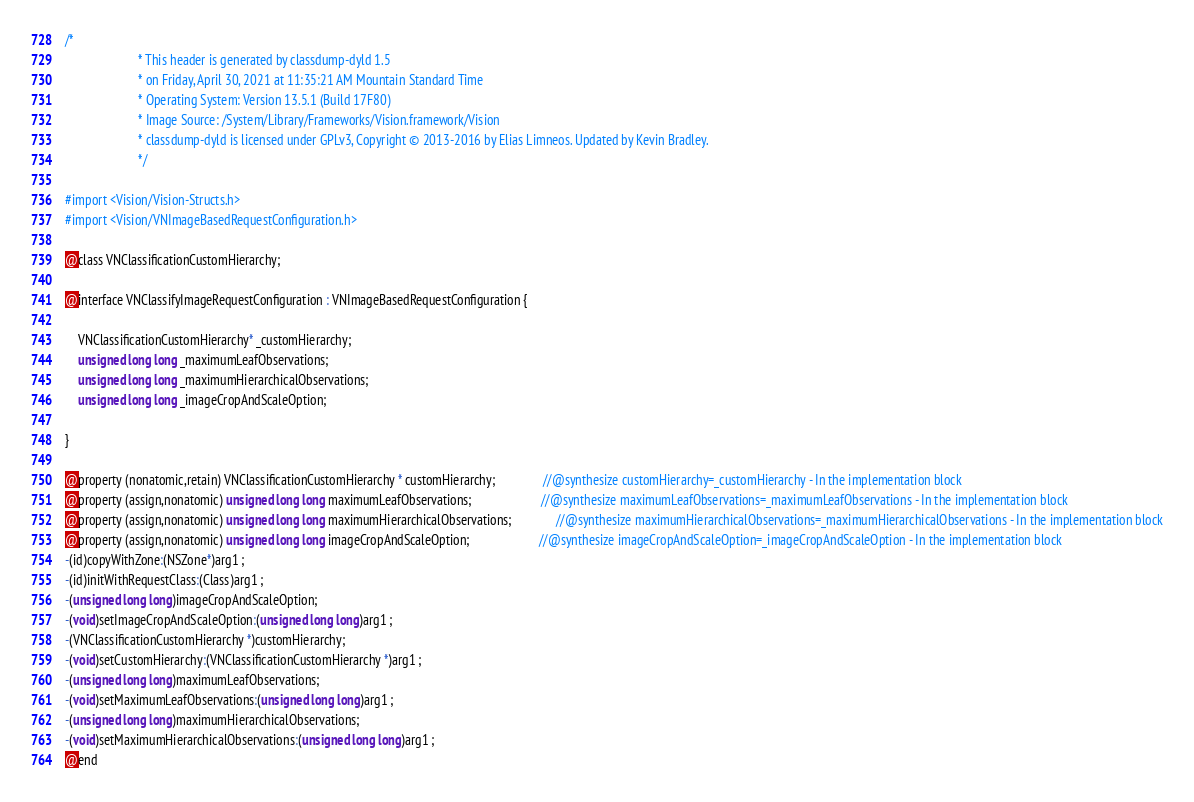<code> <loc_0><loc_0><loc_500><loc_500><_C_>/*
                       * This header is generated by classdump-dyld 1.5
                       * on Friday, April 30, 2021 at 11:35:21 AM Mountain Standard Time
                       * Operating System: Version 13.5.1 (Build 17F80)
                       * Image Source: /System/Library/Frameworks/Vision.framework/Vision
                       * classdump-dyld is licensed under GPLv3, Copyright © 2013-2016 by Elias Limneos. Updated by Kevin Bradley.
                       */

#import <Vision/Vision-Structs.h>
#import <Vision/VNImageBasedRequestConfiguration.h>

@class VNClassificationCustomHierarchy;

@interface VNClassifyImageRequestConfiguration : VNImageBasedRequestConfiguration {

	VNClassificationCustomHierarchy* _customHierarchy;
	unsigned long long _maximumLeafObservations;
	unsigned long long _maximumHierarchicalObservations;
	unsigned long long _imageCropAndScaleOption;

}

@property (nonatomic,retain) VNClassificationCustomHierarchy * customHierarchy;               //@synthesize customHierarchy=_customHierarchy - In the implementation block
@property (assign,nonatomic) unsigned long long maximumLeafObservations;                      //@synthesize maximumLeafObservations=_maximumLeafObservations - In the implementation block
@property (assign,nonatomic) unsigned long long maximumHierarchicalObservations;              //@synthesize maximumHierarchicalObservations=_maximumHierarchicalObservations - In the implementation block
@property (assign,nonatomic) unsigned long long imageCropAndScaleOption;                      //@synthesize imageCropAndScaleOption=_imageCropAndScaleOption - In the implementation block
-(id)copyWithZone:(NSZone*)arg1 ;
-(id)initWithRequestClass:(Class)arg1 ;
-(unsigned long long)imageCropAndScaleOption;
-(void)setImageCropAndScaleOption:(unsigned long long)arg1 ;
-(VNClassificationCustomHierarchy *)customHierarchy;
-(void)setCustomHierarchy:(VNClassificationCustomHierarchy *)arg1 ;
-(unsigned long long)maximumLeafObservations;
-(void)setMaximumLeafObservations:(unsigned long long)arg1 ;
-(unsigned long long)maximumHierarchicalObservations;
-(void)setMaximumHierarchicalObservations:(unsigned long long)arg1 ;
@end

</code> 